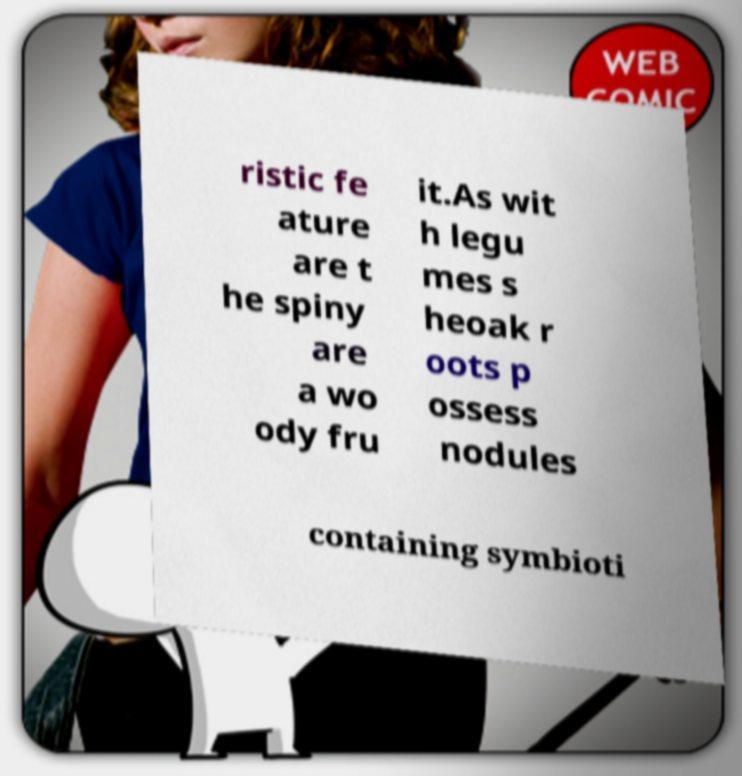Please read and relay the text visible in this image. What does it say? ristic fe ature are t he spiny are a wo ody fru it.As wit h legu mes s heoak r oots p ossess nodules containing symbioti 